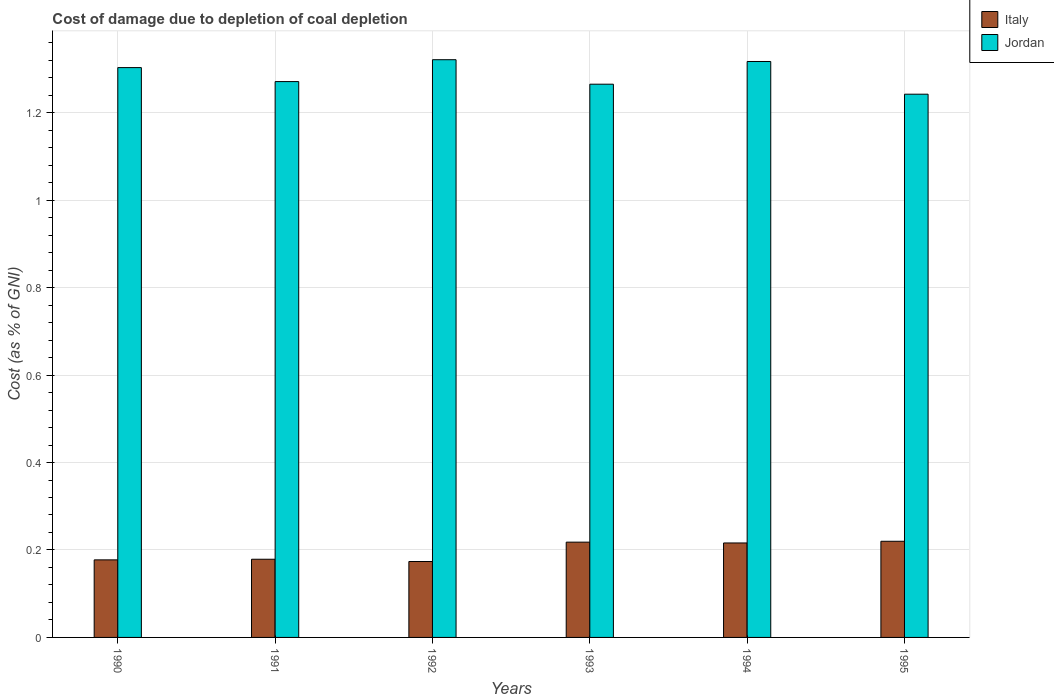Are the number of bars per tick equal to the number of legend labels?
Your answer should be compact. Yes. How many bars are there on the 1st tick from the right?
Keep it short and to the point. 2. What is the label of the 4th group of bars from the left?
Your answer should be compact. 1993. What is the cost of damage caused due to coal depletion in Italy in 1993?
Your answer should be compact. 0.22. Across all years, what is the maximum cost of damage caused due to coal depletion in Italy?
Ensure brevity in your answer.  0.22. Across all years, what is the minimum cost of damage caused due to coal depletion in Jordan?
Make the answer very short. 1.24. What is the total cost of damage caused due to coal depletion in Italy in the graph?
Keep it short and to the point. 1.18. What is the difference between the cost of damage caused due to coal depletion in Italy in 1991 and that in 1994?
Your answer should be compact. -0.04. What is the difference between the cost of damage caused due to coal depletion in Italy in 1993 and the cost of damage caused due to coal depletion in Jordan in 1995?
Give a very brief answer. -1.02. What is the average cost of damage caused due to coal depletion in Jordan per year?
Ensure brevity in your answer.  1.29. In the year 1993, what is the difference between the cost of damage caused due to coal depletion in Jordan and cost of damage caused due to coal depletion in Italy?
Offer a very short reply. 1.05. What is the ratio of the cost of damage caused due to coal depletion in Jordan in 1992 to that in 1994?
Your response must be concise. 1. What is the difference between the highest and the second highest cost of damage caused due to coal depletion in Jordan?
Keep it short and to the point. 0. What is the difference between the highest and the lowest cost of damage caused due to coal depletion in Jordan?
Provide a short and direct response. 0.08. What does the 2nd bar from the left in 1995 represents?
Provide a succinct answer. Jordan. How many bars are there?
Provide a succinct answer. 12. What is the difference between two consecutive major ticks on the Y-axis?
Keep it short and to the point. 0.2. Does the graph contain any zero values?
Give a very brief answer. No. Does the graph contain grids?
Offer a very short reply. Yes. Where does the legend appear in the graph?
Give a very brief answer. Top right. How are the legend labels stacked?
Offer a very short reply. Vertical. What is the title of the graph?
Give a very brief answer. Cost of damage due to depletion of coal depletion. What is the label or title of the Y-axis?
Make the answer very short. Cost (as % of GNI). What is the Cost (as % of GNI) of Italy in 1990?
Offer a terse response. 0.18. What is the Cost (as % of GNI) in Jordan in 1990?
Your answer should be compact. 1.3. What is the Cost (as % of GNI) in Italy in 1991?
Offer a very short reply. 0.18. What is the Cost (as % of GNI) in Jordan in 1991?
Keep it short and to the point. 1.27. What is the Cost (as % of GNI) in Italy in 1992?
Offer a terse response. 0.17. What is the Cost (as % of GNI) of Jordan in 1992?
Provide a short and direct response. 1.32. What is the Cost (as % of GNI) of Italy in 1993?
Make the answer very short. 0.22. What is the Cost (as % of GNI) of Jordan in 1993?
Provide a succinct answer. 1.27. What is the Cost (as % of GNI) of Italy in 1994?
Provide a short and direct response. 0.22. What is the Cost (as % of GNI) in Jordan in 1994?
Give a very brief answer. 1.32. What is the Cost (as % of GNI) in Italy in 1995?
Keep it short and to the point. 0.22. What is the Cost (as % of GNI) in Jordan in 1995?
Your answer should be very brief. 1.24. Across all years, what is the maximum Cost (as % of GNI) of Italy?
Keep it short and to the point. 0.22. Across all years, what is the maximum Cost (as % of GNI) of Jordan?
Provide a succinct answer. 1.32. Across all years, what is the minimum Cost (as % of GNI) of Italy?
Keep it short and to the point. 0.17. Across all years, what is the minimum Cost (as % of GNI) in Jordan?
Keep it short and to the point. 1.24. What is the total Cost (as % of GNI) in Italy in the graph?
Provide a short and direct response. 1.18. What is the total Cost (as % of GNI) in Jordan in the graph?
Your answer should be compact. 7.72. What is the difference between the Cost (as % of GNI) of Italy in 1990 and that in 1991?
Provide a succinct answer. -0. What is the difference between the Cost (as % of GNI) of Jordan in 1990 and that in 1991?
Your response must be concise. 0.03. What is the difference between the Cost (as % of GNI) in Italy in 1990 and that in 1992?
Give a very brief answer. 0. What is the difference between the Cost (as % of GNI) of Jordan in 1990 and that in 1992?
Your answer should be very brief. -0.02. What is the difference between the Cost (as % of GNI) of Italy in 1990 and that in 1993?
Offer a very short reply. -0.04. What is the difference between the Cost (as % of GNI) in Jordan in 1990 and that in 1993?
Offer a very short reply. 0.04. What is the difference between the Cost (as % of GNI) of Italy in 1990 and that in 1994?
Your response must be concise. -0.04. What is the difference between the Cost (as % of GNI) in Jordan in 1990 and that in 1994?
Keep it short and to the point. -0.01. What is the difference between the Cost (as % of GNI) in Italy in 1990 and that in 1995?
Ensure brevity in your answer.  -0.04. What is the difference between the Cost (as % of GNI) of Jordan in 1990 and that in 1995?
Offer a terse response. 0.06. What is the difference between the Cost (as % of GNI) of Italy in 1991 and that in 1992?
Keep it short and to the point. 0.01. What is the difference between the Cost (as % of GNI) of Jordan in 1991 and that in 1992?
Your response must be concise. -0.05. What is the difference between the Cost (as % of GNI) of Italy in 1991 and that in 1993?
Provide a succinct answer. -0.04. What is the difference between the Cost (as % of GNI) of Jordan in 1991 and that in 1993?
Your response must be concise. 0.01. What is the difference between the Cost (as % of GNI) in Italy in 1991 and that in 1994?
Give a very brief answer. -0.04. What is the difference between the Cost (as % of GNI) of Jordan in 1991 and that in 1994?
Provide a short and direct response. -0.05. What is the difference between the Cost (as % of GNI) in Italy in 1991 and that in 1995?
Offer a terse response. -0.04. What is the difference between the Cost (as % of GNI) in Jordan in 1991 and that in 1995?
Give a very brief answer. 0.03. What is the difference between the Cost (as % of GNI) in Italy in 1992 and that in 1993?
Your answer should be compact. -0.04. What is the difference between the Cost (as % of GNI) in Jordan in 1992 and that in 1993?
Provide a succinct answer. 0.06. What is the difference between the Cost (as % of GNI) of Italy in 1992 and that in 1994?
Provide a succinct answer. -0.04. What is the difference between the Cost (as % of GNI) in Jordan in 1992 and that in 1994?
Ensure brevity in your answer.  0. What is the difference between the Cost (as % of GNI) in Italy in 1992 and that in 1995?
Give a very brief answer. -0.05. What is the difference between the Cost (as % of GNI) in Jordan in 1992 and that in 1995?
Your answer should be very brief. 0.08. What is the difference between the Cost (as % of GNI) of Italy in 1993 and that in 1994?
Offer a terse response. 0. What is the difference between the Cost (as % of GNI) of Jordan in 1993 and that in 1994?
Your response must be concise. -0.05. What is the difference between the Cost (as % of GNI) in Italy in 1993 and that in 1995?
Your answer should be compact. -0. What is the difference between the Cost (as % of GNI) of Jordan in 1993 and that in 1995?
Give a very brief answer. 0.02. What is the difference between the Cost (as % of GNI) in Italy in 1994 and that in 1995?
Offer a very short reply. -0. What is the difference between the Cost (as % of GNI) in Jordan in 1994 and that in 1995?
Offer a terse response. 0.07. What is the difference between the Cost (as % of GNI) of Italy in 1990 and the Cost (as % of GNI) of Jordan in 1991?
Keep it short and to the point. -1.09. What is the difference between the Cost (as % of GNI) in Italy in 1990 and the Cost (as % of GNI) in Jordan in 1992?
Provide a short and direct response. -1.14. What is the difference between the Cost (as % of GNI) in Italy in 1990 and the Cost (as % of GNI) in Jordan in 1993?
Make the answer very short. -1.09. What is the difference between the Cost (as % of GNI) of Italy in 1990 and the Cost (as % of GNI) of Jordan in 1994?
Your response must be concise. -1.14. What is the difference between the Cost (as % of GNI) of Italy in 1990 and the Cost (as % of GNI) of Jordan in 1995?
Your response must be concise. -1.06. What is the difference between the Cost (as % of GNI) of Italy in 1991 and the Cost (as % of GNI) of Jordan in 1992?
Give a very brief answer. -1.14. What is the difference between the Cost (as % of GNI) in Italy in 1991 and the Cost (as % of GNI) in Jordan in 1993?
Provide a succinct answer. -1.09. What is the difference between the Cost (as % of GNI) of Italy in 1991 and the Cost (as % of GNI) of Jordan in 1994?
Your response must be concise. -1.14. What is the difference between the Cost (as % of GNI) in Italy in 1991 and the Cost (as % of GNI) in Jordan in 1995?
Your answer should be very brief. -1.06. What is the difference between the Cost (as % of GNI) of Italy in 1992 and the Cost (as % of GNI) of Jordan in 1993?
Offer a terse response. -1.09. What is the difference between the Cost (as % of GNI) of Italy in 1992 and the Cost (as % of GNI) of Jordan in 1994?
Keep it short and to the point. -1.14. What is the difference between the Cost (as % of GNI) of Italy in 1992 and the Cost (as % of GNI) of Jordan in 1995?
Offer a very short reply. -1.07. What is the difference between the Cost (as % of GNI) in Italy in 1993 and the Cost (as % of GNI) in Jordan in 1994?
Your response must be concise. -1.1. What is the difference between the Cost (as % of GNI) of Italy in 1993 and the Cost (as % of GNI) of Jordan in 1995?
Provide a succinct answer. -1.02. What is the difference between the Cost (as % of GNI) in Italy in 1994 and the Cost (as % of GNI) in Jordan in 1995?
Offer a very short reply. -1.03. What is the average Cost (as % of GNI) of Italy per year?
Offer a very short reply. 0.2. What is the average Cost (as % of GNI) of Jordan per year?
Your response must be concise. 1.29. In the year 1990, what is the difference between the Cost (as % of GNI) in Italy and Cost (as % of GNI) in Jordan?
Your answer should be very brief. -1.13. In the year 1991, what is the difference between the Cost (as % of GNI) in Italy and Cost (as % of GNI) in Jordan?
Give a very brief answer. -1.09. In the year 1992, what is the difference between the Cost (as % of GNI) in Italy and Cost (as % of GNI) in Jordan?
Keep it short and to the point. -1.15. In the year 1993, what is the difference between the Cost (as % of GNI) of Italy and Cost (as % of GNI) of Jordan?
Offer a terse response. -1.05. In the year 1994, what is the difference between the Cost (as % of GNI) in Italy and Cost (as % of GNI) in Jordan?
Provide a succinct answer. -1.1. In the year 1995, what is the difference between the Cost (as % of GNI) of Italy and Cost (as % of GNI) of Jordan?
Provide a succinct answer. -1.02. What is the ratio of the Cost (as % of GNI) of Italy in 1990 to that in 1991?
Your answer should be compact. 0.99. What is the ratio of the Cost (as % of GNI) in Jordan in 1990 to that in 1991?
Provide a short and direct response. 1.03. What is the ratio of the Cost (as % of GNI) of Italy in 1990 to that in 1992?
Give a very brief answer. 1.02. What is the ratio of the Cost (as % of GNI) of Jordan in 1990 to that in 1992?
Offer a very short reply. 0.99. What is the ratio of the Cost (as % of GNI) in Italy in 1990 to that in 1993?
Your response must be concise. 0.81. What is the ratio of the Cost (as % of GNI) in Italy in 1990 to that in 1994?
Offer a very short reply. 0.82. What is the ratio of the Cost (as % of GNI) of Italy in 1990 to that in 1995?
Ensure brevity in your answer.  0.81. What is the ratio of the Cost (as % of GNI) in Jordan in 1990 to that in 1995?
Offer a very short reply. 1.05. What is the ratio of the Cost (as % of GNI) in Italy in 1991 to that in 1992?
Provide a short and direct response. 1.03. What is the ratio of the Cost (as % of GNI) in Jordan in 1991 to that in 1992?
Ensure brevity in your answer.  0.96. What is the ratio of the Cost (as % of GNI) in Italy in 1991 to that in 1993?
Your response must be concise. 0.82. What is the ratio of the Cost (as % of GNI) in Italy in 1991 to that in 1994?
Your response must be concise. 0.83. What is the ratio of the Cost (as % of GNI) in Jordan in 1991 to that in 1994?
Your answer should be very brief. 0.97. What is the ratio of the Cost (as % of GNI) in Italy in 1991 to that in 1995?
Provide a succinct answer. 0.81. What is the ratio of the Cost (as % of GNI) of Jordan in 1991 to that in 1995?
Keep it short and to the point. 1.02. What is the ratio of the Cost (as % of GNI) in Italy in 1992 to that in 1993?
Provide a succinct answer. 0.8. What is the ratio of the Cost (as % of GNI) in Jordan in 1992 to that in 1993?
Make the answer very short. 1.04. What is the ratio of the Cost (as % of GNI) of Italy in 1992 to that in 1994?
Give a very brief answer. 0.8. What is the ratio of the Cost (as % of GNI) in Jordan in 1992 to that in 1994?
Make the answer very short. 1. What is the ratio of the Cost (as % of GNI) in Italy in 1992 to that in 1995?
Keep it short and to the point. 0.79. What is the ratio of the Cost (as % of GNI) of Jordan in 1992 to that in 1995?
Offer a very short reply. 1.06. What is the ratio of the Cost (as % of GNI) in Italy in 1993 to that in 1994?
Offer a very short reply. 1.01. What is the ratio of the Cost (as % of GNI) of Jordan in 1993 to that in 1994?
Your answer should be very brief. 0.96. What is the ratio of the Cost (as % of GNI) in Jordan in 1993 to that in 1995?
Your response must be concise. 1.02. What is the ratio of the Cost (as % of GNI) in Italy in 1994 to that in 1995?
Provide a short and direct response. 0.98. What is the ratio of the Cost (as % of GNI) in Jordan in 1994 to that in 1995?
Your answer should be compact. 1.06. What is the difference between the highest and the second highest Cost (as % of GNI) of Italy?
Provide a short and direct response. 0. What is the difference between the highest and the second highest Cost (as % of GNI) of Jordan?
Provide a succinct answer. 0. What is the difference between the highest and the lowest Cost (as % of GNI) of Italy?
Keep it short and to the point. 0.05. What is the difference between the highest and the lowest Cost (as % of GNI) in Jordan?
Make the answer very short. 0.08. 